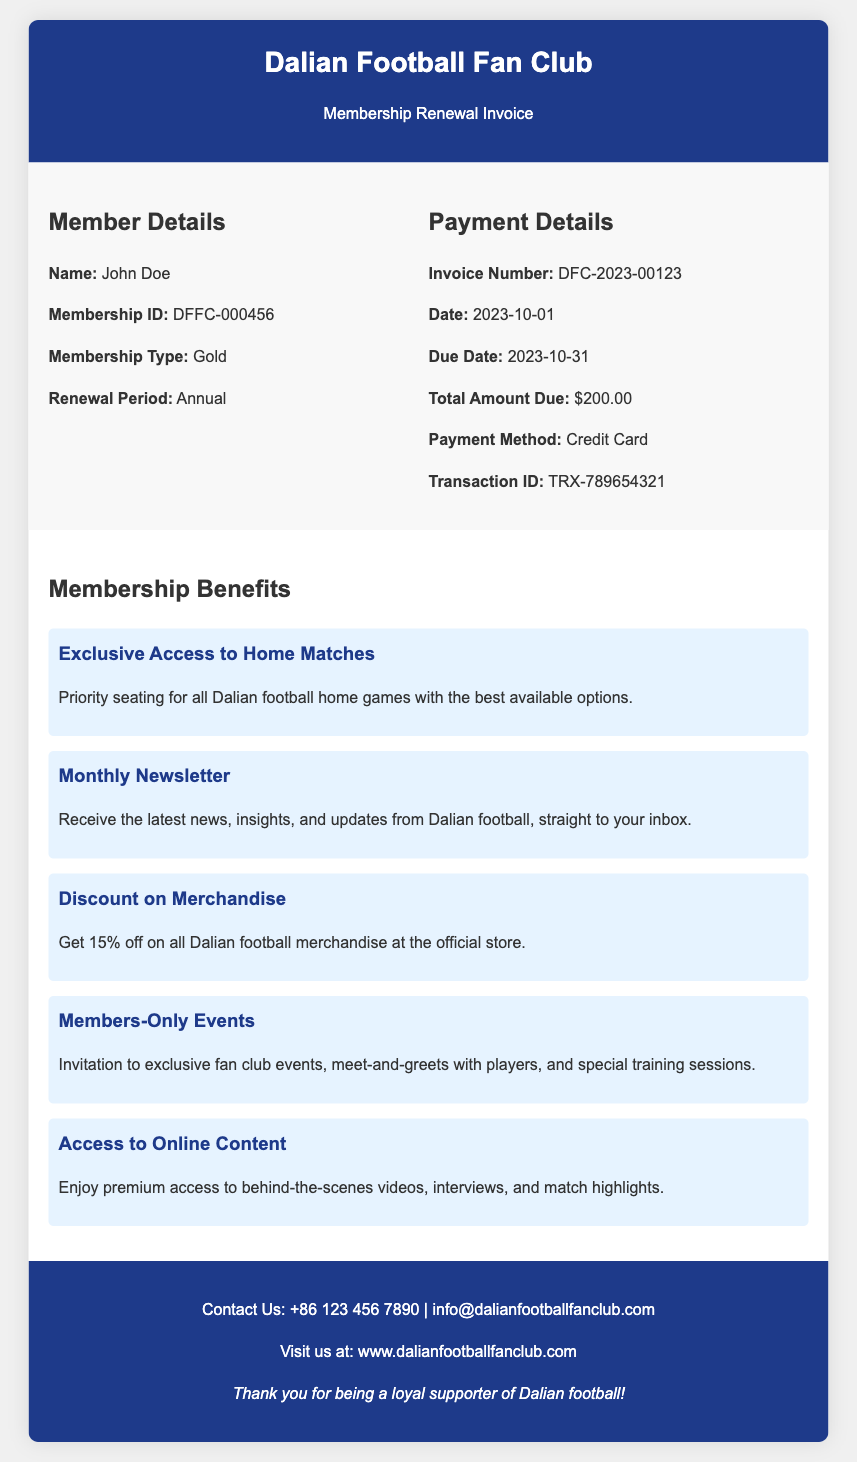What is the member's name? The member's name is listed under Member Details in the document.
Answer: John Doe What is the membership type? The membership type is specified in the Member Details section of the invoice.
Answer: Gold What is the total amount due? The total amount due is clearly stated in the Payment Details section of the document.
Answer: $200.00 What is the renewal period? The renewal period is indicated in the Member Details section of the invoice.
Answer: Annual What is the invoice number? The invoice number is mentioned in the Payment Details section.
Answer: DFC-2023-00123 What percentage discount do members receive on merchandise? The discount percentage is specified in the Membership Benefits section of the document.
Answer: 15% What benefit includes access to meet-and-greets with players? This benefit is outlined in the Membership Benefits section.
Answer: Members-Only Events What is the payment method used for this transaction? The payment method is provided in the Payment Details of the document.
Answer: Credit Card When is the due date for the payment? The due date for the payment can be found in the Payment Details section.
Answer: 2023-10-31 